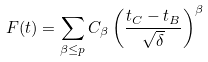Convert formula to latex. <formula><loc_0><loc_0><loc_500><loc_500>F ( t ) = \sum _ { \beta \leq p } C _ { \beta } \left ( \frac { t _ { C } - t _ { B } } { \sqrt { \delta } } \right ) ^ { \beta }</formula> 